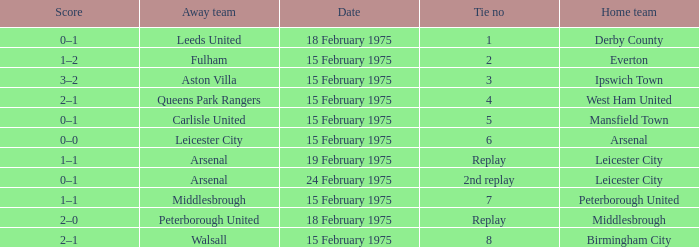What was the date when the away team was carlisle united? 15 February 1975. 